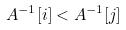Convert formula to latex. <formula><loc_0><loc_0><loc_500><loc_500>A ^ { - 1 } [ i ] < A ^ { - 1 } [ j ]</formula> 